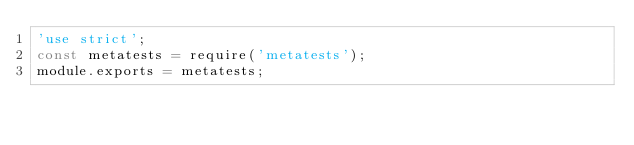Convert code to text. <code><loc_0><loc_0><loc_500><loc_500><_JavaScript_>'use strict';
const metatests = require('metatests');
module.exports = metatests;</code> 